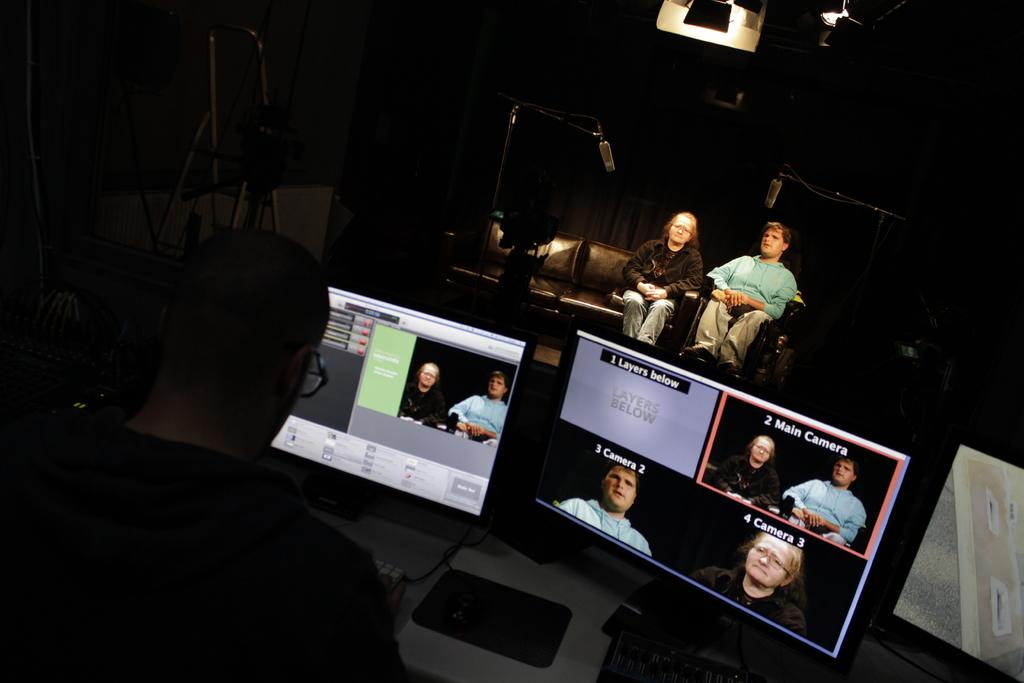<image>
Share a concise interpretation of the image provided. Person looking at a monitor that says 1 Layers Below on it. 